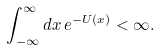Convert formula to latex. <formula><loc_0><loc_0><loc_500><loc_500>\int _ { - \infty } ^ { \infty } d x \, e ^ { - U ( x ) } < \infty .</formula> 